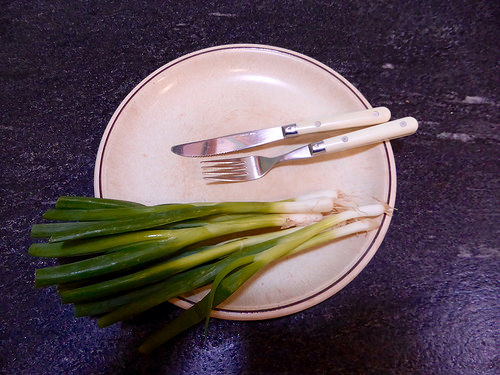<image>
Can you confirm if the fork is to the left of the leek? No. The fork is not to the left of the leek. From this viewpoint, they have a different horizontal relationship. Where is the vegetable in relation to the plate? Is it in the plate? Yes. The vegetable is contained within or inside the plate, showing a containment relationship. 